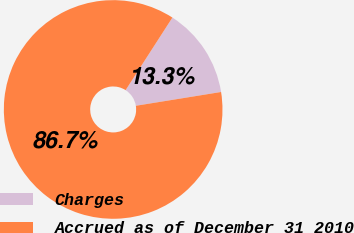Convert chart to OTSL. <chart><loc_0><loc_0><loc_500><loc_500><pie_chart><fcel>Charges<fcel>Accrued as of December 31 2010<nl><fcel>13.33%<fcel>86.67%<nl></chart> 